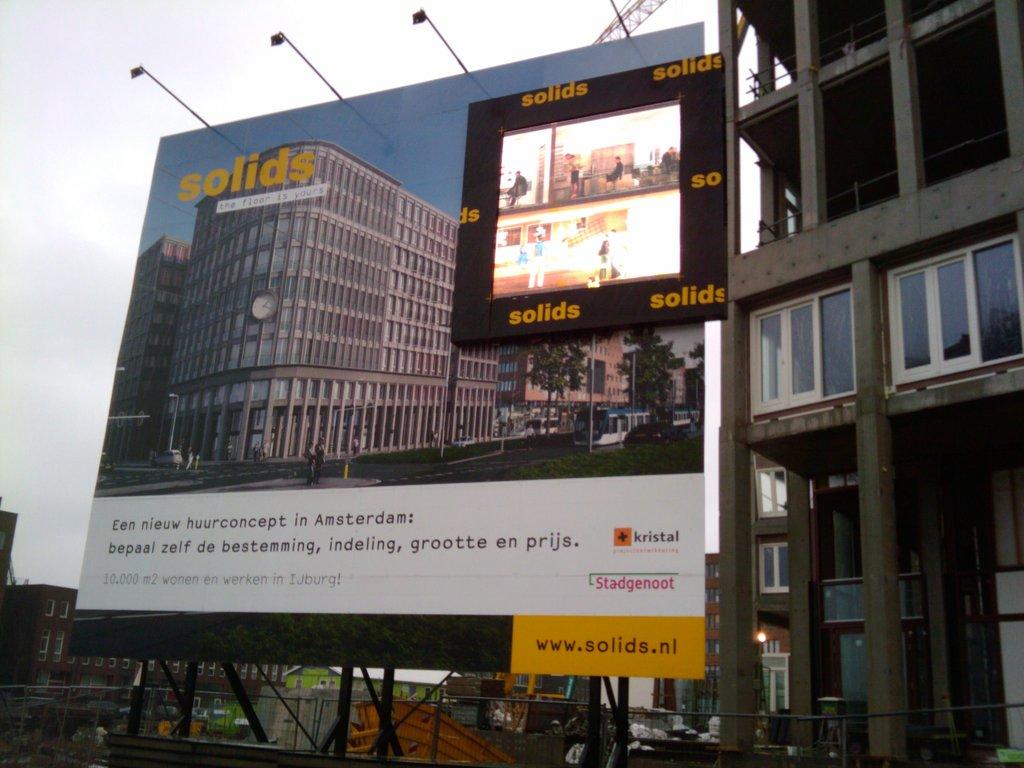What website is on the bottom?
Provide a short and direct response. Www.solids.nl. 